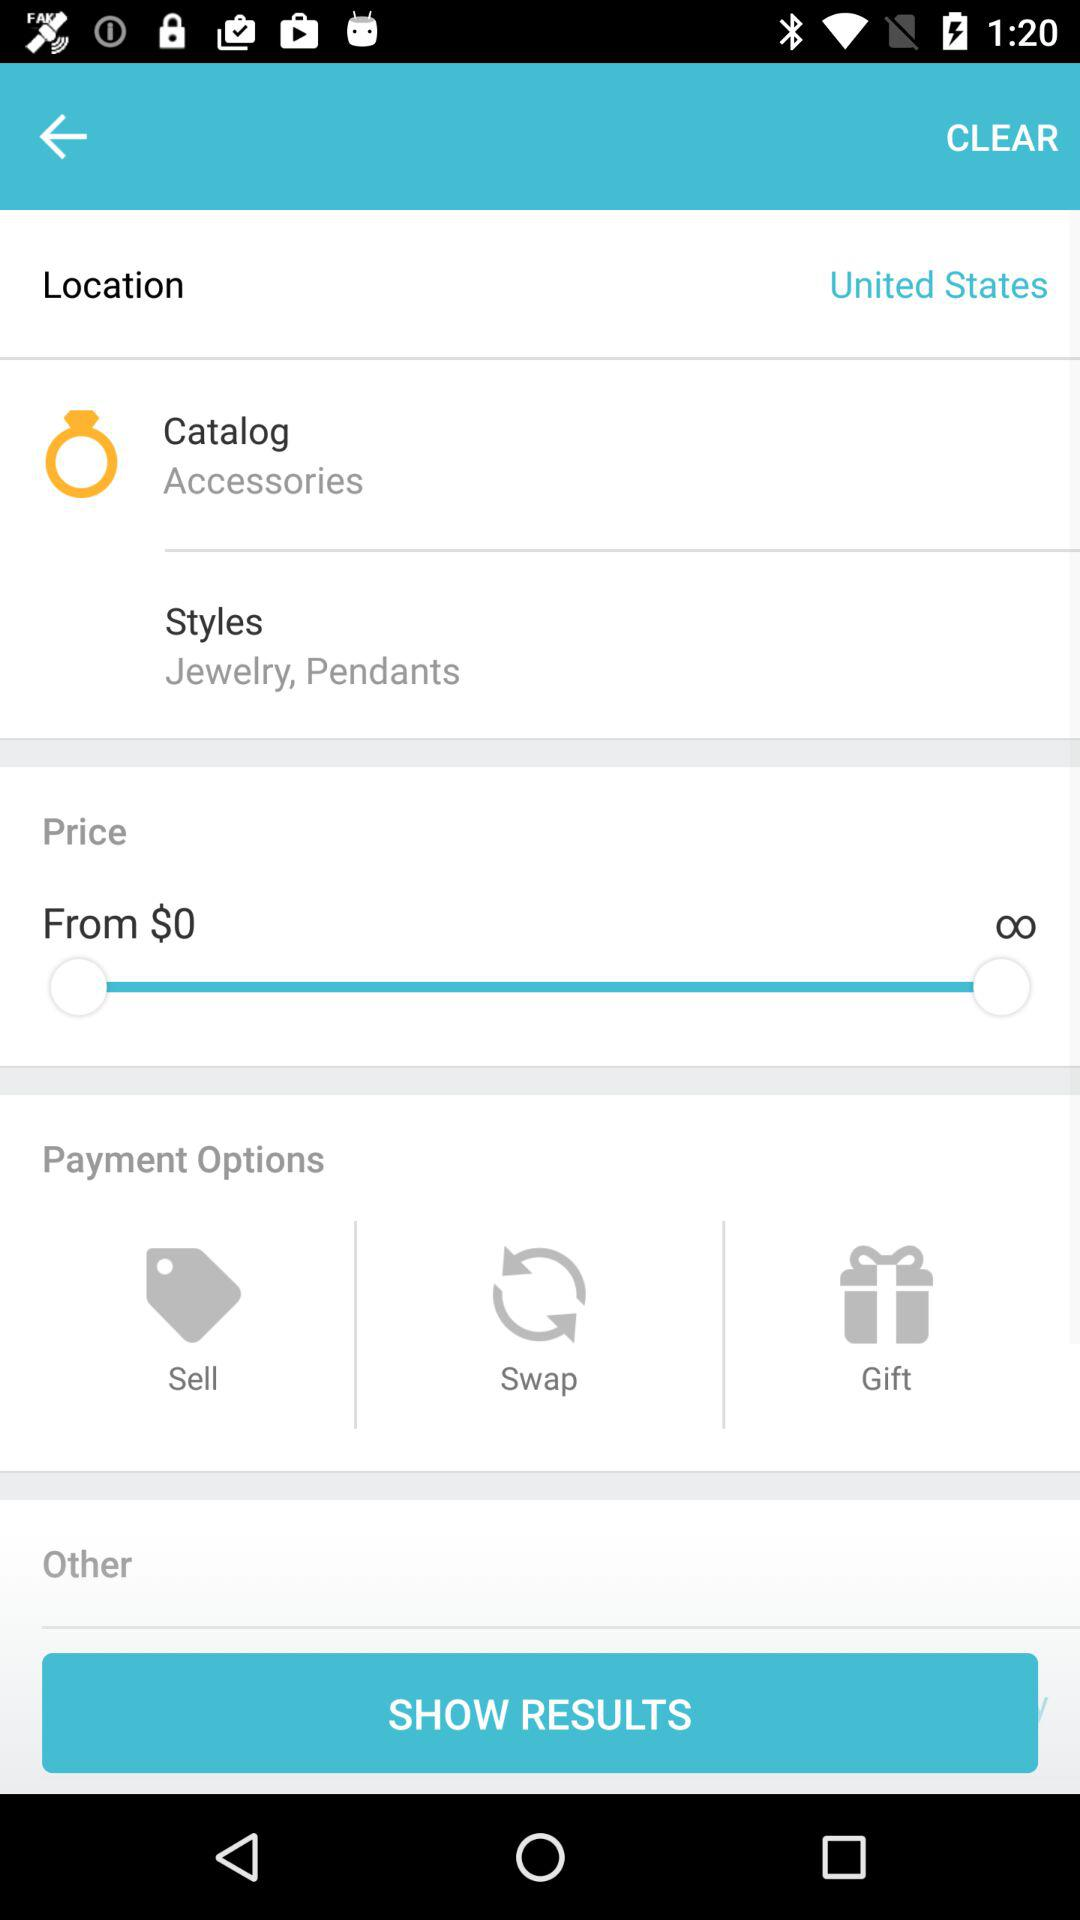What are the styles available in accessories? The available styles in accessories are jewelry and pendants. 